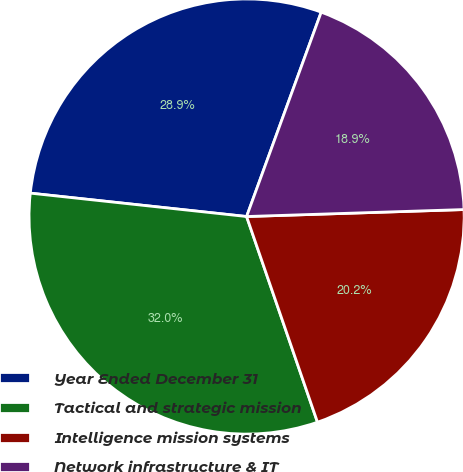Convert chart. <chart><loc_0><loc_0><loc_500><loc_500><pie_chart><fcel>Year Ended December 31<fcel>Tactical and strategic mission<fcel>Intelligence mission systems<fcel>Network infrastructure & IT<nl><fcel>28.86%<fcel>32.0%<fcel>20.23%<fcel>18.92%<nl></chart> 